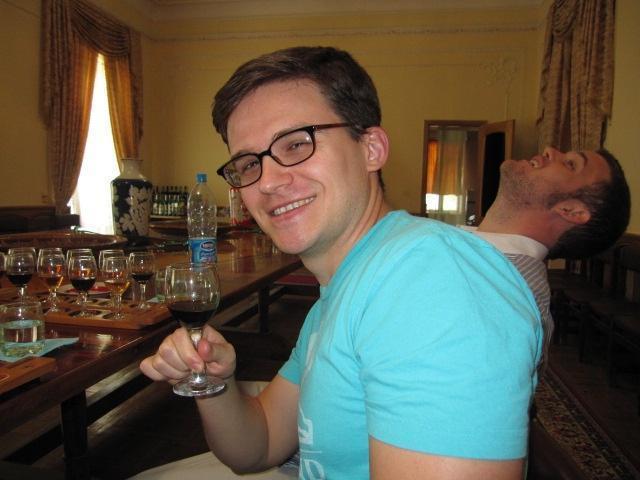How many people can you see?
Give a very brief answer. 2. How many chairs are in the photo?
Give a very brief answer. 2. How many elephants are there?
Give a very brief answer. 0. 